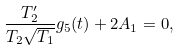<formula> <loc_0><loc_0><loc_500><loc_500>\frac { T ^ { \prime } _ { 2 } } { T _ { 2 } \sqrt { T _ { 1 } } } g _ { 5 } ( t ) + 2 A _ { 1 } = 0 ,</formula> 